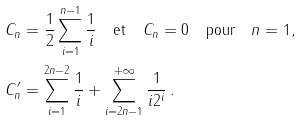<formula> <loc_0><loc_0><loc_500><loc_500>C _ { n } & = \frac { 1 } { 2 } \sum _ { i = 1 } ^ { n - 1 } \frac { 1 } { i } \quad \text {et} \quad C _ { n } = 0 \quad \text {pour} \quad n = 1 , \\ C _ { n } ^ { \prime } & = \sum _ { i = 1 } ^ { 2 n - 2 } \frac { 1 } { i } + \sum _ { i = 2 n - 1 } ^ { + \infty } \frac { 1 } { i 2 ^ { i } } \, .</formula> 